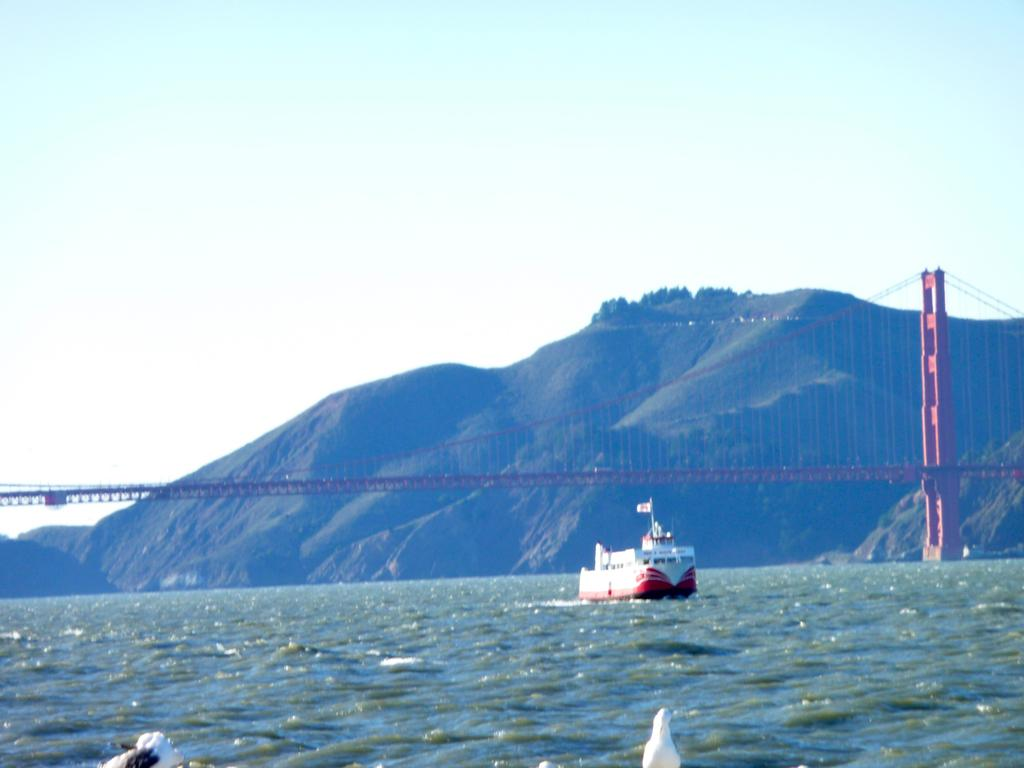What is the main subject of the image? The main subject of the image is a ship. Where is the ship located? The ship is on the water. What can be seen behind the ship? There is a bridge behind the ship. What is located behind the bridge? There is a hill behind the bridge. What is visible in the background of the image? The sky is visible in the image. What type of stem can be seen growing from the ship in the image? There is no stem growing from the ship in the image. What is the title of the book that the frog is reading on the ship? There is no frog or book present in the image. 